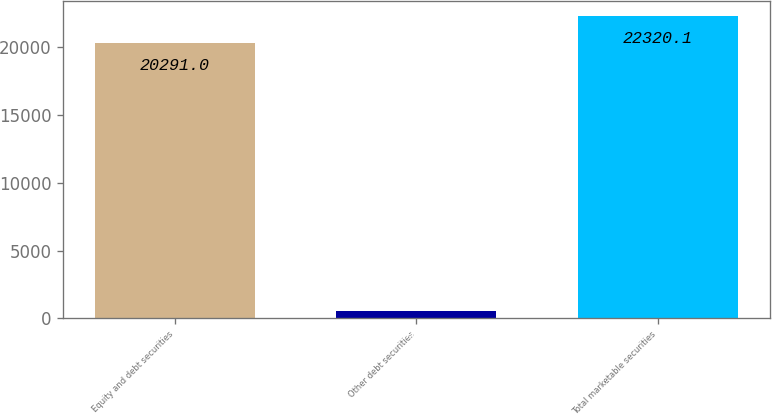Convert chart to OTSL. <chart><loc_0><loc_0><loc_500><loc_500><bar_chart><fcel>Equity and debt securities<fcel>Other debt securities<fcel>Total marketable securities<nl><fcel>20291<fcel>548<fcel>22320.1<nl></chart> 